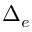<formula> <loc_0><loc_0><loc_500><loc_500>\Delta _ { e }</formula> 